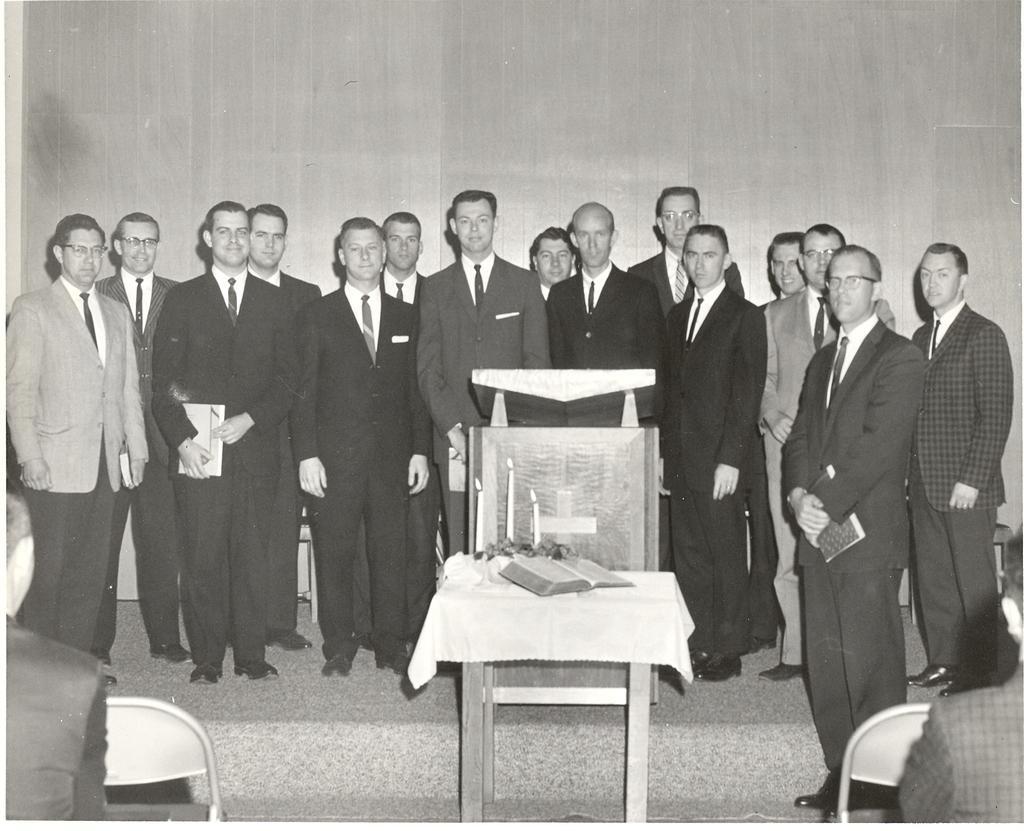Describe this image in one or two sentences. In this picture i can see a group of people standing on the floor. In the middle i can see a chair ,in the chair i can see a table cloth kept on the chair and there is a book kept on the chair. On the right another chair is kept ,on the left i can see a another. In the background i can see a wall. 